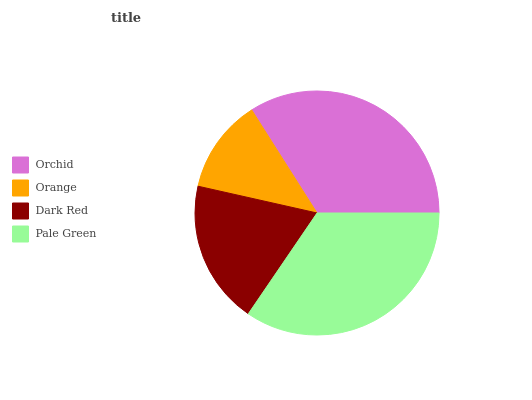Is Orange the minimum?
Answer yes or no. Yes. Is Pale Green the maximum?
Answer yes or no. Yes. Is Dark Red the minimum?
Answer yes or no. No. Is Dark Red the maximum?
Answer yes or no. No. Is Dark Red greater than Orange?
Answer yes or no. Yes. Is Orange less than Dark Red?
Answer yes or no. Yes. Is Orange greater than Dark Red?
Answer yes or no. No. Is Dark Red less than Orange?
Answer yes or no. No. Is Orchid the high median?
Answer yes or no. Yes. Is Dark Red the low median?
Answer yes or no. Yes. Is Orange the high median?
Answer yes or no. No. Is Orchid the low median?
Answer yes or no. No. 